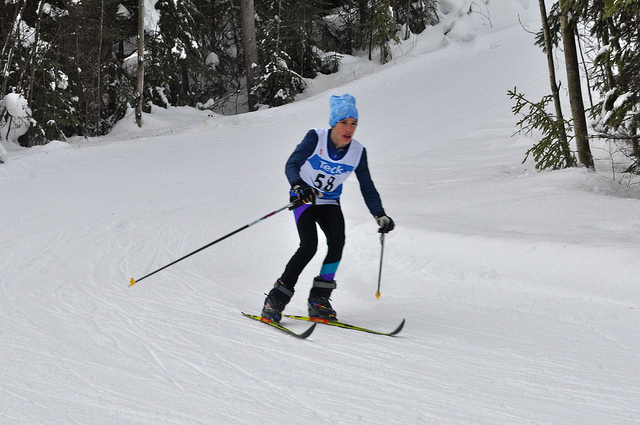Please identify all text content in this image. Teck 58 